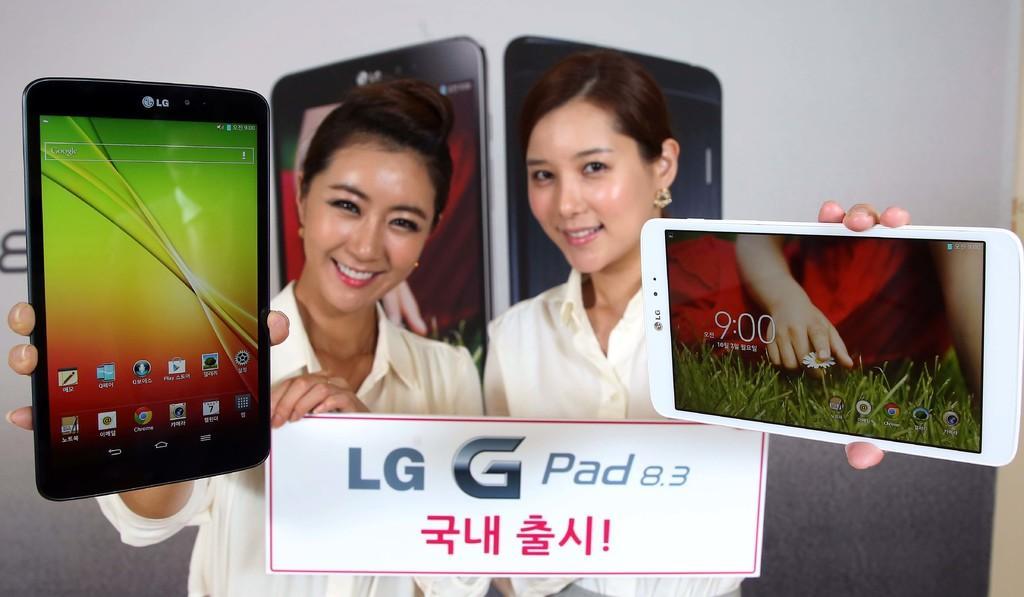Describe this image in one or two sentences. In this picture we can see two women in the middle. They are smiling. And they are holding a mobile with their hands. 